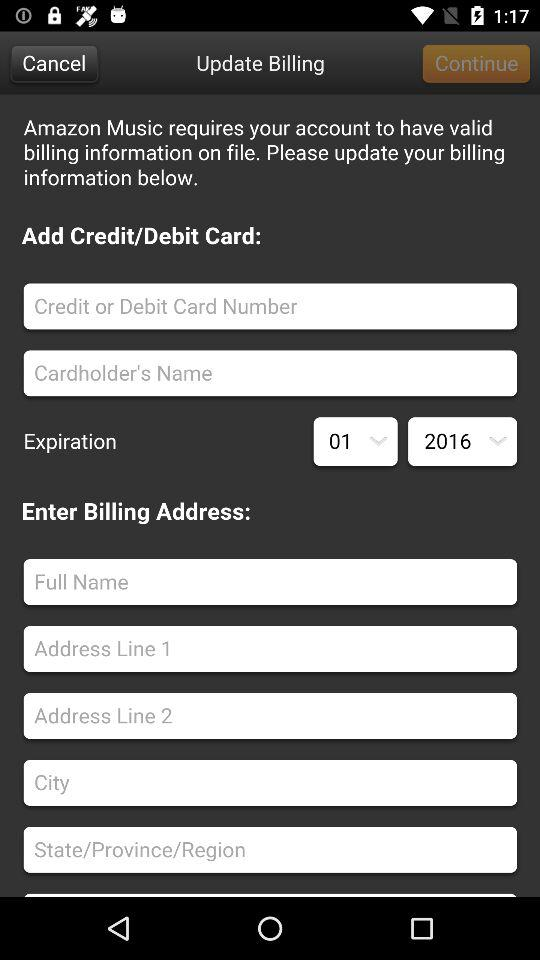How many text inputs are there for the credit/debit card?
Answer the question using a single word or phrase. 2 